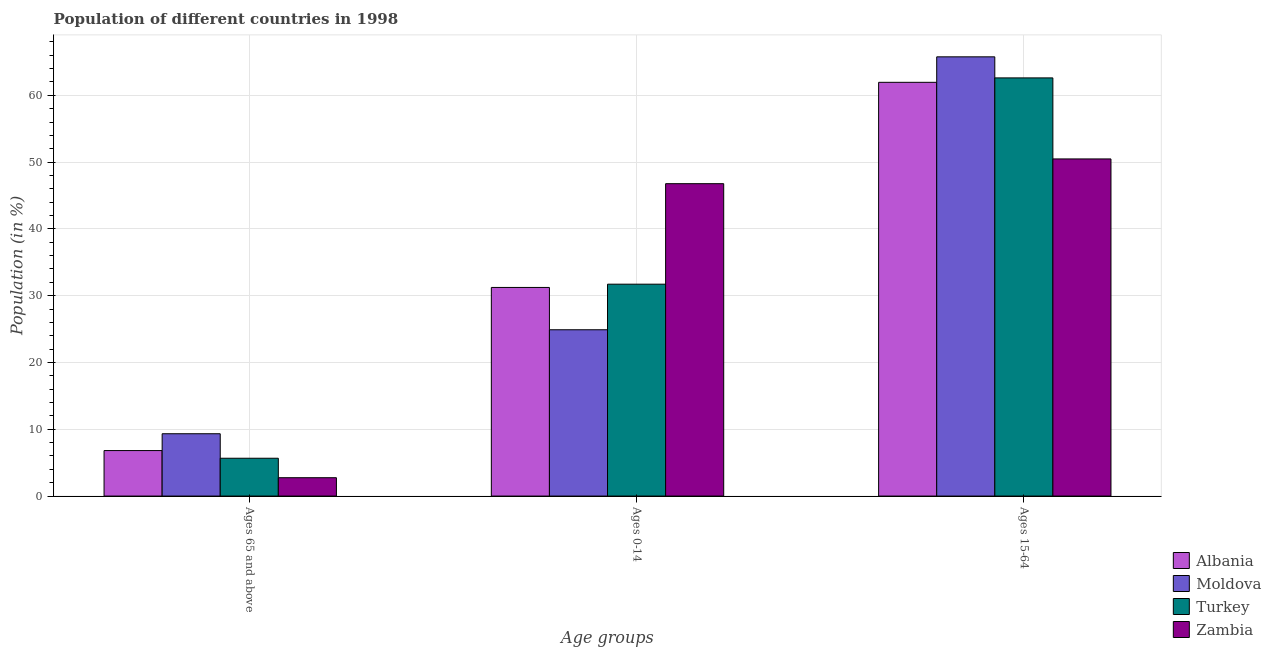How many bars are there on the 2nd tick from the left?
Ensure brevity in your answer.  4. How many bars are there on the 3rd tick from the right?
Your answer should be compact. 4. What is the label of the 3rd group of bars from the left?
Your answer should be very brief. Ages 15-64. What is the percentage of population within the age-group 15-64 in Albania?
Offer a very short reply. 61.95. Across all countries, what is the maximum percentage of population within the age-group of 65 and above?
Your answer should be very brief. 9.33. Across all countries, what is the minimum percentage of population within the age-group 15-64?
Offer a very short reply. 50.48. In which country was the percentage of population within the age-group 15-64 maximum?
Offer a terse response. Moldova. In which country was the percentage of population within the age-group of 65 and above minimum?
Give a very brief answer. Zambia. What is the total percentage of population within the age-group 15-64 in the graph?
Provide a succinct answer. 240.81. What is the difference between the percentage of population within the age-group 15-64 in Moldova and that in Turkey?
Your answer should be very brief. 3.15. What is the difference between the percentage of population within the age-group of 65 and above in Moldova and the percentage of population within the age-group 0-14 in Turkey?
Provide a succinct answer. -22.39. What is the average percentage of population within the age-group 0-14 per country?
Give a very brief answer. 33.66. What is the difference between the percentage of population within the age-group of 65 and above and percentage of population within the age-group 0-14 in Albania?
Your answer should be compact. -24.42. What is the ratio of the percentage of population within the age-group 0-14 in Albania to that in Moldova?
Your answer should be very brief. 1.25. Is the percentage of population within the age-group of 65 and above in Moldova less than that in Albania?
Make the answer very short. No. Is the difference between the percentage of population within the age-group 0-14 in Moldova and Albania greater than the difference between the percentage of population within the age-group 15-64 in Moldova and Albania?
Provide a succinct answer. No. What is the difference between the highest and the second highest percentage of population within the age-group 15-64?
Give a very brief answer. 3.15. What is the difference between the highest and the lowest percentage of population within the age-group 15-64?
Give a very brief answer. 15.29. In how many countries, is the percentage of population within the age-group of 65 and above greater than the average percentage of population within the age-group of 65 and above taken over all countries?
Your answer should be compact. 2. Is the sum of the percentage of population within the age-group of 65 and above in Moldova and Albania greater than the maximum percentage of population within the age-group 15-64 across all countries?
Offer a terse response. No. What does the 1st bar from the right in Ages 15-64 represents?
Give a very brief answer. Zambia. Is it the case that in every country, the sum of the percentage of population within the age-group of 65 and above and percentage of population within the age-group 0-14 is greater than the percentage of population within the age-group 15-64?
Ensure brevity in your answer.  No. How many countries are there in the graph?
Your answer should be very brief. 4. Are the values on the major ticks of Y-axis written in scientific E-notation?
Your answer should be very brief. No. Does the graph contain any zero values?
Ensure brevity in your answer.  No. Where does the legend appear in the graph?
Your answer should be very brief. Bottom right. What is the title of the graph?
Ensure brevity in your answer.  Population of different countries in 1998. Does "Korea (Republic)" appear as one of the legend labels in the graph?
Ensure brevity in your answer.  No. What is the label or title of the X-axis?
Provide a short and direct response. Age groups. What is the label or title of the Y-axis?
Ensure brevity in your answer.  Population (in %). What is the Population (in %) of Albania in Ages 65 and above?
Provide a succinct answer. 6.81. What is the Population (in %) of Moldova in Ages 65 and above?
Provide a short and direct response. 9.33. What is the Population (in %) of Turkey in Ages 65 and above?
Your response must be concise. 5.66. What is the Population (in %) of Zambia in Ages 65 and above?
Ensure brevity in your answer.  2.75. What is the Population (in %) of Albania in Ages 0-14?
Provide a succinct answer. 31.24. What is the Population (in %) of Moldova in Ages 0-14?
Your answer should be very brief. 24.9. What is the Population (in %) in Turkey in Ages 0-14?
Provide a short and direct response. 31.72. What is the Population (in %) of Zambia in Ages 0-14?
Your answer should be very brief. 46.77. What is the Population (in %) of Albania in Ages 15-64?
Ensure brevity in your answer.  61.95. What is the Population (in %) of Moldova in Ages 15-64?
Keep it short and to the point. 65.77. What is the Population (in %) of Turkey in Ages 15-64?
Offer a very short reply. 62.61. What is the Population (in %) in Zambia in Ages 15-64?
Make the answer very short. 50.48. Across all Age groups, what is the maximum Population (in %) in Albania?
Provide a succinct answer. 61.95. Across all Age groups, what is the maximum Population (in %) in Moldova?
Keep it short and to the point. 65.77. Across all Age groups, what is the maximum Population (in %) in Turkey?
Keep it short and to the point. 62.61. Across all Age groups, what is the maximum Population (in %) in Zambia?
Your answer should be very brief. 50.48. Across all Age groups, what is the minimum Population (in %) of Albania?
Your answer should be very brief. 6.81. Across all Age groups, what is the minimum Population (in %) in Moldova?
Give a very brief answer. 9.33. Across all Age groups, what is the minimum Population (in %) of Turkey?
Make the answer very short. 5.66. Across all Age groups, what is the minimum Population (in %) of Zambia?
Your response must be concise. 2.75. What is the total Population (in %) of Zambia in the graph?
Your response must be concise. 100. What is the difference between the Population (in %) of Albania in Ages 65 and above and that in Ages 0-14?
Provide a short and direct response. -24.42. What is the difference between the Population (in %) of Moldova in Ages 65 and above and that in Ages 0-14?
Provide a succinct answer. -15.57. What is the difference between the Population (in %) of Turkey in Ages 65 and above and that in Ages 0-14?
Make the answer very short. -26.06. What is the difference between the Population (in %) of Zambia in Ages 65 and above and that in Ages 0-14?
Provide a short and direct response. -44.03. What is the difference between the Population (in %) of Albania in Ages 65 and above and that in Ages 15-64?
Provide a short and direct response. -55.14. What is the difference between the Population (in %) in Moldova in Ages 65 and above and that in Ages 15-64?
Provide a succinct answer. -56.43. What is the difference between the Population (in %) of Turkey in Ages 65 and above and that in Ages 15-64?
Ensure brevity in your answer.  -56.95. What is the difference between the Population (in %) in Zambia in Ages 65 and above and that in Ages 15-64?
Ensure brevity in your answer.  -47.73. What is the difference between the Population (in %) of Albania in Ages 0-14 and that in Ages 15-64?
Give a very brief answer. -30.71. What is the difference between the Population (in %) of Moldova in Ages 0-14 and that in Ages 15-64?
Offer a terse response. -40.86. What is the difference between the Population (in %) of Turkey in Ages 0-14 and that in Ages 15-64?
Provide a short and direct response. -30.89. What is the difference between the Population (in %) in Zambia in Ages 0-14 and that in Ages 15-64?
Ensure brevity in your answer.  -3.7. What is the difference between the Population (in %) of Albania in Ages 65 and above and the Population (in %) of Moldova in Ages 0-14?
Ensure brevity in your answer.  -18.09. What is the difference between the Population (in %) of Albania in Ages 65 and above and the Population (in %) of Turkey in Ages 0-14?
Offer a terse response. -24.91. What is the difference between the Population (in %) of Albania in Ages 65 and above and the Population (in %) of Zambia in Ages 0-14?
Provide a short and direct response. -39.96. What is the difference between the Population (in %) of Moldova in Ages 65 and above and the Population (in %) of Turkey in Ages 0-14?
Your answer should be very brief. -22.39. What is the difference between the Population (in %) of Moldova in Ages 65 and above and the Population (in %) of Zambia in Ages 0-14?
Ensure brevity in your answer.  -37.44. What is the difference between the Population (in %) in Turkey in Ages 65 and above and the Population (in %) in Zambia in Ages 0-14?
Offer a very short reply. -41.11. What is the difference between the Population (in %) in Albania in Ages 65 and above and the Population (in %) in Moldova in Ages 15-64?
Keep it short and to the point. -58.95. What is the difference between the Population (in %) of Albania in Ages 65 and above and the Population (in %) of Turkey in Ages 15-64?
Ensure brevity in your answer.  -55.8. What is the difference between the Population (in %) in Albania in Ages 65 and above and the Population (in %) in Zambia in Ages 15-64?
Offer a terse response. -43.67. What is the difference between the Population (in %) of Moldova in Ages 65 and above and the Population (in %) of Turkey in Ages 15-64?
Your answer should be very brief. -53.28. What is the difference between the Population (in %) of Moldova in Ages 65 and above and the Population (in %) of Zambia in Ages 15-64?
Keep it short and to the point. -41.15. What is the difference between the Population (in %) in Turkey in Ages 65 and above and the Population (in %) in Zambia in Ages 15-64?
Your response must be concise. -44.82. What is the difference between the Population (in %) of Albania in Ages 0-14 and the Population (in %) of Moldova in Ages 15-64?
Provide a short and direct response. -34.53. What is the difference between the Population (in %) in Albania in Ages 0-14 and the Population (in %) in Turkey in Ages 15-64?
Provide a short and direct response. -31.38. What is the difference between the Population (in %) of Albania in Ages 0-14 and the Population (in %) of Zambia in Ages 15-64?
Your answer should be very brief. -19.24. What is the difference between the Population (in %) in Moldova in Ages 0-14 and the Population (in %) in Turkey in Ages 15-64?
Offer a terse response. -37.71. What is the difference between the Population (in %) in Moldova in Ages 0-14 and the Population (in %) in Zambia in Ages 15-64?
Make the answer very short. -25.58. What is the difference between the Population (in %) of Turkey in Ages 0-14 and the Population (in %) of Zambia in Ages 15-64?
Provide a succinct answer. -18.75. What is the average Population (in %) of Albania per Age groups?
Offer a very short reply. 33.33. What is the average Population (in %) in Moldova per Age groups?
Offer a terse response. 33.33. What is the average Population (in %) of Turkey per Age groups?
Ensure brevity in your answer.  33.33. What is the average Population (in %) of Zambia per Age groups?
Provide a succinct answer. 33.33. What is the difference between the Population (in %) in Albania and Population (in %) in Moldova in Ages 65 and above?
Your answer should be compact. -2.52. What is the difference between the Population (in %) of Albania and Population (in %) of Turkey in Ages 65 and above?
Your answer should be very brief. 1.15. What is the difference between the Population (in %) in Albania and Population (in %) in Zambia in Ages 65 and above?
Your answer should be very brief. 4.06. What is the difference between the Population (in %) in Moldova and Population (in %) in Turkey in Ages 65 and above?
Your answer should be very brief. 3.67. What is the difference between the Population (in %) of Moldova and Population (in %) of Zambia in Ages 65 and above?
Keep it short and to the point. 6.58. What is the difference between the Population (in %) of Turkey and Population (in %) of Zambia in Ages 65 and above?
Offer a terse response. 2.92. What is the difference between the Population (in %) of Albania and Population (in %) of Moldova in Ages 0-14?
Your answer should be very brief. 6.34. What is the difference between the Population (in %) in Albania and Population (in %) in Turkey in Ages 0-14?
Your response must be concise. -0.49. What is the difference between the Population (in %) in Albania and Population (in %) in Zambia in Ages 0-14?
Offer a very short reply. -15.54. What is the difference between the Population (in %) in Moldova and Population (in %) in Turkey in Ages 0-14?
Provide a short and direct response. -6.82. What is the difference between the Population (in %) in Moldova and Population (in %) in Zambia in Ages 0-14?
Your response must be concise. -21.87. What is the difference between the Population (in %) of Turkey and Population (in %) of Zambia in Ages 0-14?
Your answer should be compact. -15.05. What is the difference between the Population (in %) of Albania and Population (in %) of Moldova in Ages 15-64?
Offer a terse response. -3.82. What is the difference between the Population (in %) of Albania and Population (in %) of Turkey in Ages 15-64?
Ensure brevity in your answer.  -0.66. What is the difference between the Population (in %) of Albania and Population (in %) of Zambia in Ages 15-64?
Ensure brevity in your answer.  11.47. What is the difference between the Population (in %) in Moldova and Population (in %) in Turkey in Ages 15-64?
Provide a short and direct response. 3.15. What is the difference between the Population (in %) of Moldova and Population (in %) of Zambia in Ages 15-64?
Ensure brevity in your answer.  15.29. What is the difference between the Population (in %) in Turkey and Population (in %) in Zambia in Ages 15-64?
Offer a very short reply. 12.13. What is the ratio of the Population (in %) in Albania in Ages 65 and above to that in Ages 0-14?
Your answer should be very brief. 0.22. What is the ratio of the Population (in %) of Moldova in Ages 65 and above to that in Ages 0-14?
Your answer should be compact. 0.37. What is the ratio of the Population (in %) of Turkey in Ages 65 and above to that in Ages 0-14?
Your answer should be compact. 0.18. What is the ratio of the Population (in %) of Zambia in Ages 65 and above to that in Ages 0-14?
Your answer should be very brief. 0.06. What is the ratio of the Population (in %) of Albania in Ages 65 and above to that in Ages 15-64?
Ensure brevity in your answer.  0.11. What is the ratio of the Population (in %) in Moldova in Ages 65 and above to that in Ages 15-64?
Give a very brief answer. 0.14. What is the ratio of the Population (in %) of Turkey in Ages 65 and above to that in Ages 15-64?
Your answer should be very brief. 0.09. What is the ratio of the Population (in %) of Zambia in Ages 65 and above to that in Ages 15-64?
Your answer should be very brief. 0.05. What is the ratio of the Population (in %) in Albania in Ages 0-14 to that in Ages 15-64?
Give a very brief answer. 0.5. What is the ratio of the Population (in %) in Moldova in Ages 0-14 to that in Ages 15-64?
Your answer should be very brief. 0.38. What is the ratio of the Population (in %) in Turkey in Ages 0-14 to that in Ages 15-64?
Provide a short and direct response. 0.51. What is the ratio of the Population (in %) in Zambia in Ages 0-14 to that in Ages 15-64?
Keep it short and to the point. 0.93. What is the difference between the highest and the second highest Population (in %) in Albania?
Give a very brief answer. 30.71. What is the difference between the highest and the second highest Population (in %) of Moldova?
Make the answer very short. 40.86. What is the difference between the highest and the second highest Population (in %) in Turkey?
Offer a very short reply. 30.89. What is the difference between the highest and the second highest Population (in %) of Zambia?
Make the answer very short. 3.7. What is the difference between the highest and the lowest Population (in %) in Albania?
Provide a short and direct response. 55.14. What is the difference between the highest and the lowest Population (in %) in Moldova?
Provide a short and direct response. 56.43. What is the difference between the highest and the lowest Population (in %) in Turkey?
Ensure brevity in your answer.  56.95. What is the difference between the highest and the lowest Population (in %) of Zambia?
Provide a succinct answer. 47.73. 